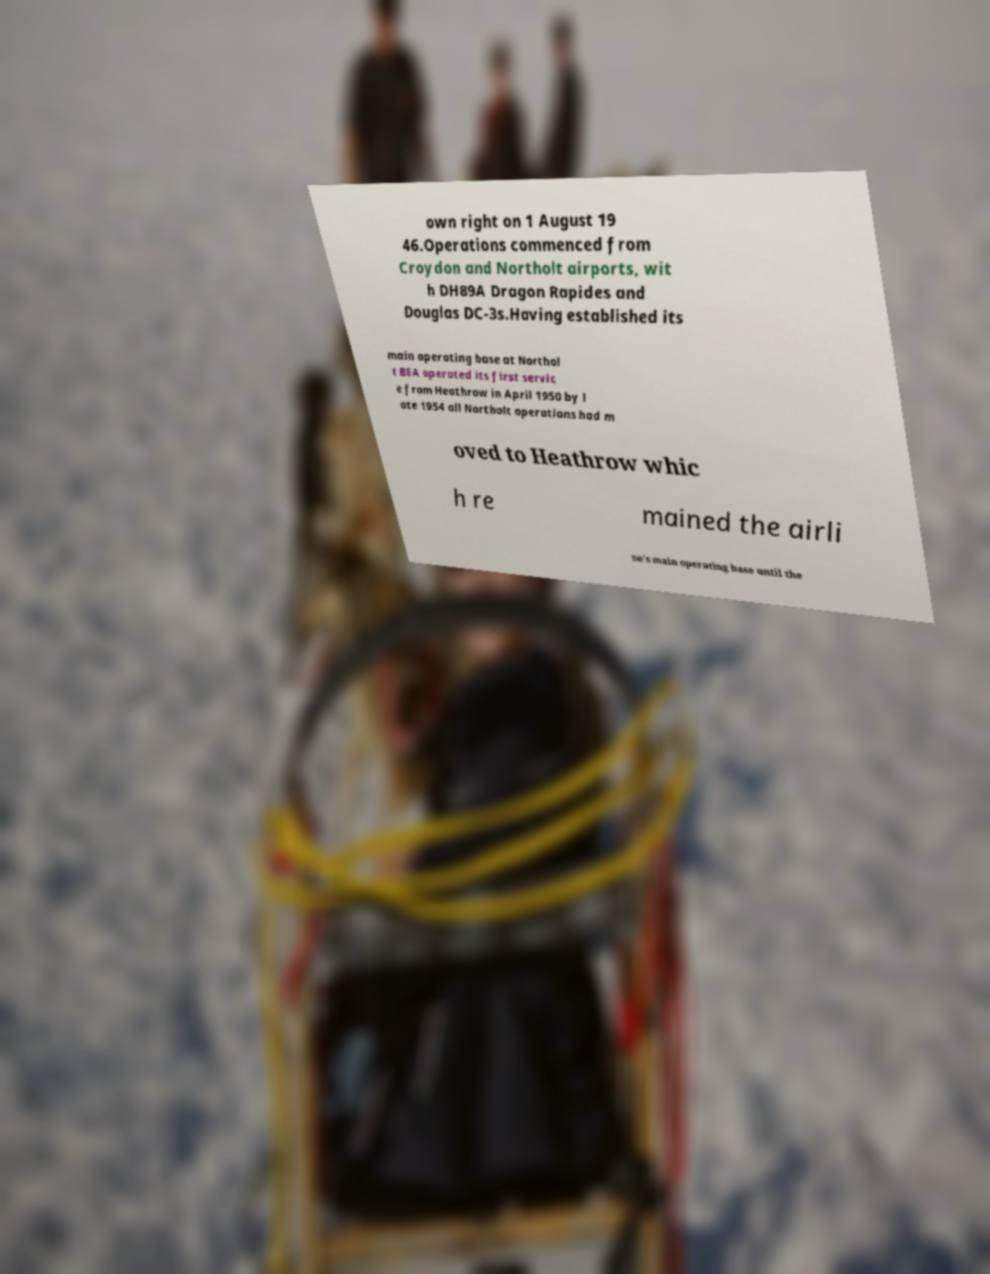There's text embedded in this image that I need extracted. Can you transcribe it verbatim? own right on 1 August 19 46.Operations commenced from Croydon and Northolt airports, wit h DH89A Dragon Rapides and Douglas DC-3s.Having established its main operating base at Northol t BEA operated its first servic e from Heathrow in April 1950 by l ate 1954 all Northolt operations had m oved to Heathrow whic h re mained the airli ne's main operating base until the 